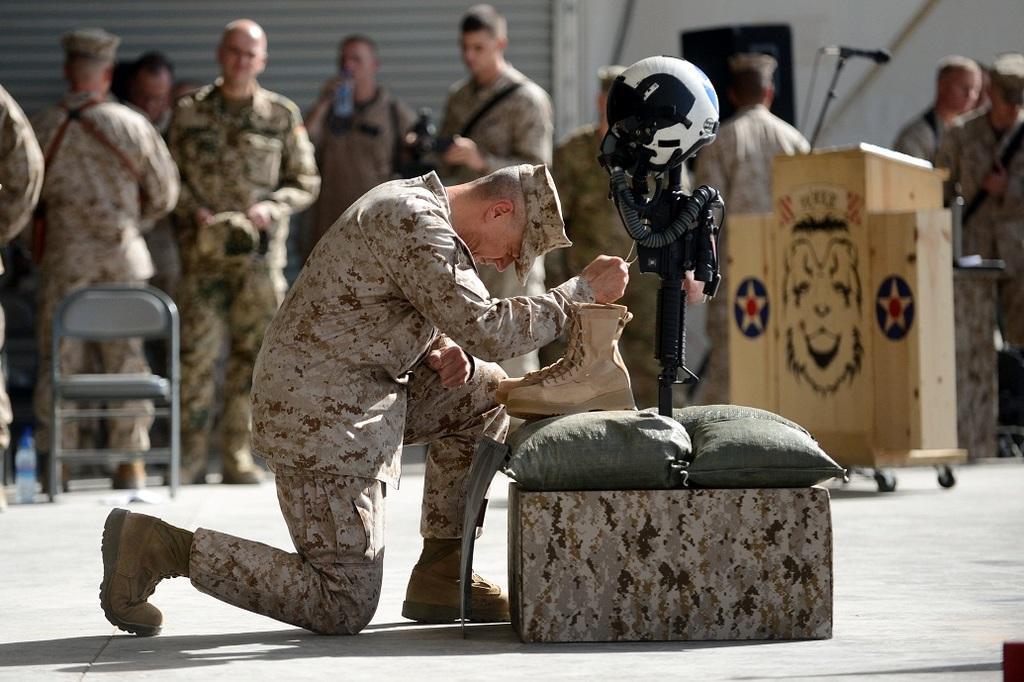Can you describe this image briefly? In the image in the center we can see one person,box,pillow,stand,helmet and pair of shoes. And we can see the person is holding thread. In the background there is a shutter,wall,box,chair,water bottle and few other objects.  